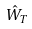<formula> <loc_0><loc_0><loc_500><loc_500>\hat { W } _ { T }</formula> 